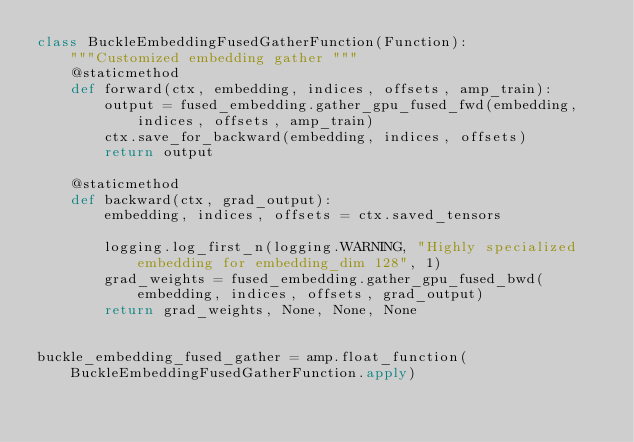Convert code to text. <code><loc_0><loc_0><loc_500><loc_500><_Python_>class BuckleEmbeddingFusedGatherFunction(Function):
    """Customized embedding gather """
    @staticmethod
    def forward(ctx, embedding, indices, offsets, amp_train):
        output = fused_embedding.gather_gpu_fused_fwd(embedding, indices, offsets, amp_train)
        ctx.save_for_backward(embedding, indices, offsets)
        return output

    @staticmethod
    def backward(ctx, grad_output):
        embedding, indices, offsets = ctx.saved_tensors

        logging.log_first_n(logging.WARNING, "Highly specialized embedding for embedding_dim 128", 1)
        grad_weights = fused_embedding.gather_gpu_fused_bwd(embedding, indices, offsets, grad_output)
        return grad_weights, None, None, None


buckle_embedding_fused_gather = amp.float_function(BuckleEmbeddingFusedGatherFunction.apply)
</code> 